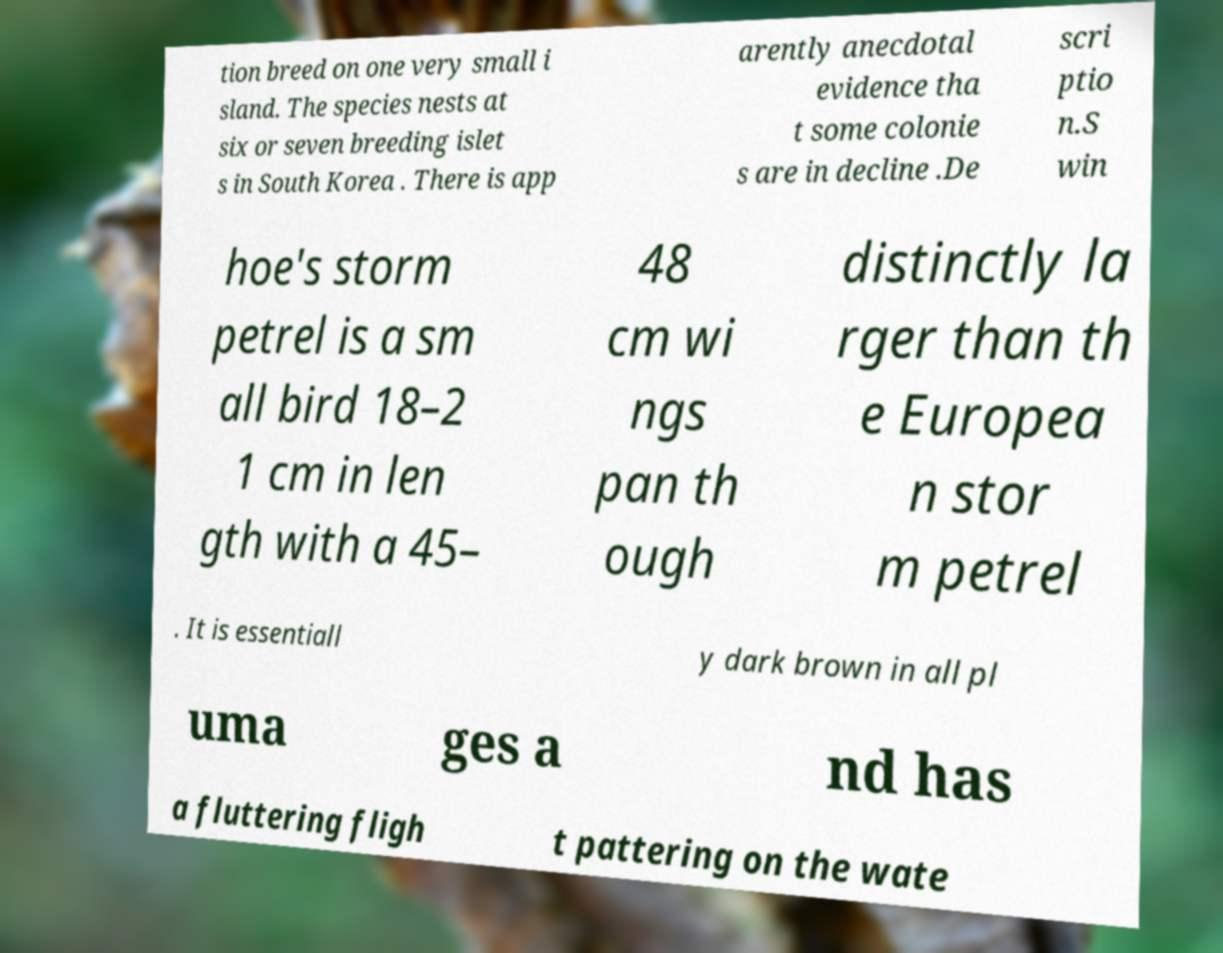For documentation purposes, I need the text within this image transcribed. Could you provide that? tion breed on one very small i sland. The species nests at six or seven breeding islet s in South Korea . There is app arently anecdotal evidence tha t some colonie s are in decline .De scri ptio n.S win hoe's storm petrel is a sm all bird 18–2 1 cm in len gth with a 45– 48 cm wi ngs pan th ough distinctly la rger than th e Europea n stor m petrel . It is essentiall y dark brown in all pl uma ges a nd has a fluttering fligh t pattering on the wate 